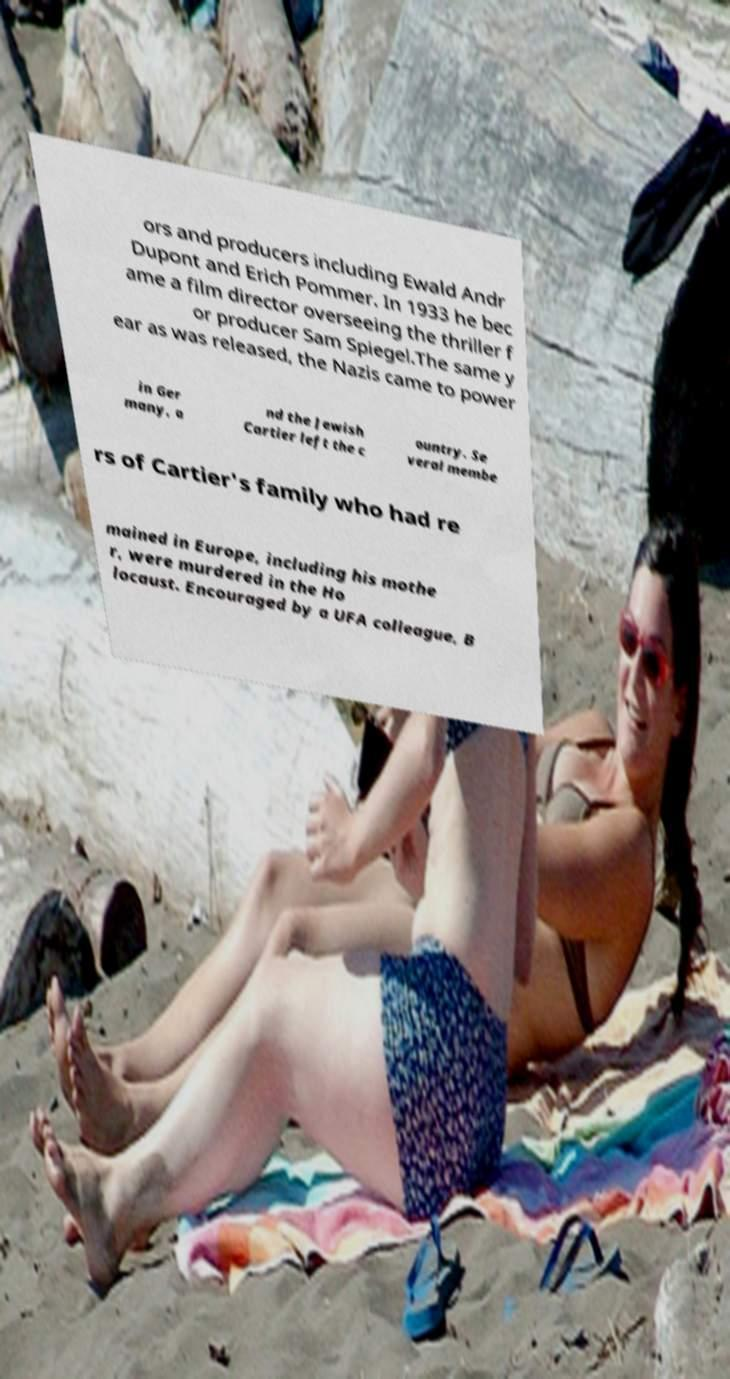Please read and relay the text visible in this image. What does it say? ors and producers including Ewald Andr Dupont and Erich Pommer. In 1933 he bec ame a film director overseeing the thriller f or producer Sam Spiegel.The same y ear as was released, the Nazis came to power in Ger many, a nd the Jewish Cartier left the c ountry. Se veral membe rs of Cartier's family who had re mained in Europe, including his mothe r, were murdered in the Ho locaust. Encouraged by a UFA colleague, B 